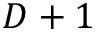<formula> <loc_0><loc_0><loc_500><loc_500>D + 1</formula> 